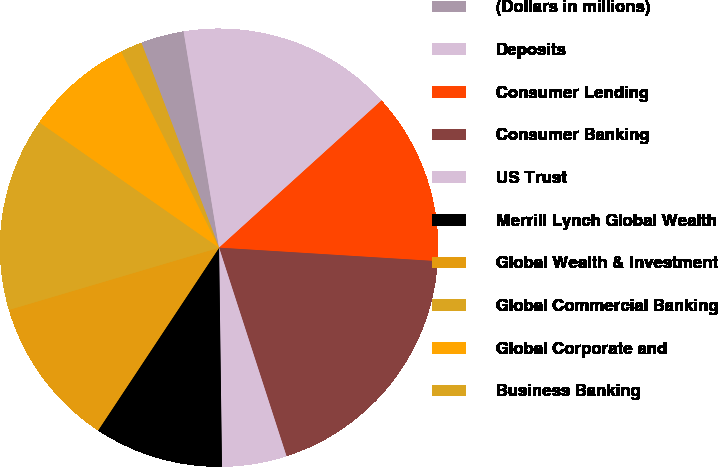Convert chart to OTSL. <chart><loc_0><loc_0><loc_500><loc_500><pie_chart><fcel>(Dollars in millions)<fcel>Deposits<fcel>Consumer Lending<fcel>Consumer Banking<fcel>US Trust<fcel>Merrill Lynch Global Wealth<fcel>Global Wealth & Investment<fcel>Global Commercial Banking<fcel>Global Corporate and<fcel>Business Banking<nl><fcel>3.18%<fcel>15.87%<fcel>12.7%<fcel>19.04%<fcel>4.77%<fcel>9.52%<fcel>11.11%<fcel>14.28%<fcel>7.94%<fcel>1.6%<nl></chart> 